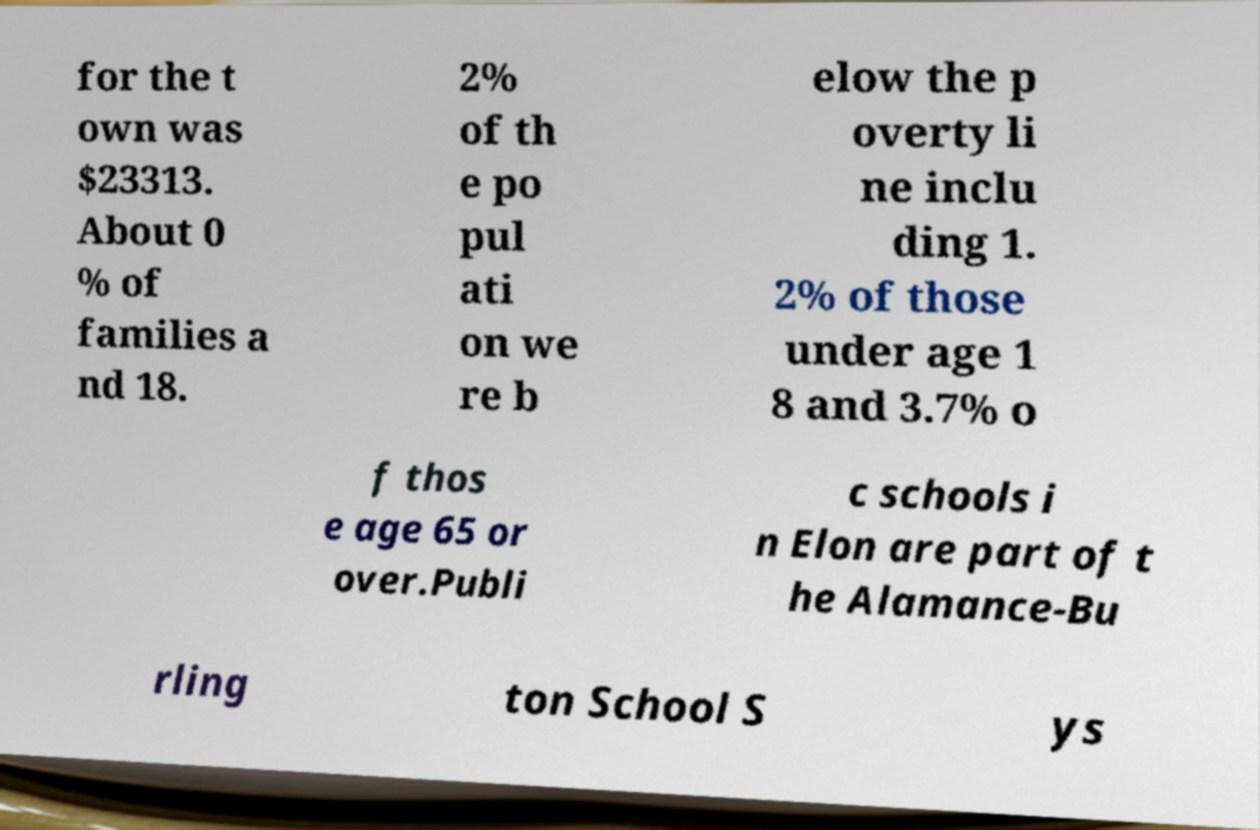I need the written content from this picture converted into text. Can you do that? for the t own was $23313. About 0 % of families a nd 18. 2% of th e po pul ati on we re b elow the p overty li ne inclu ding 1. 2% of those under age 1 8 and 3.7% o f thos e age 65 or over.Publi c schools i n Elon are part of t he Alamance-Bu rling ton School S ys 